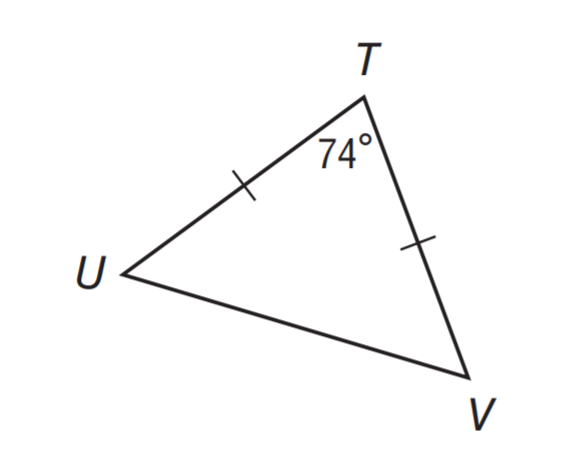Question: Find m \angle T U V.
Choices:
A. 16
B. 37
C. 53
D. 74
Answer with the letter. Answer: C 